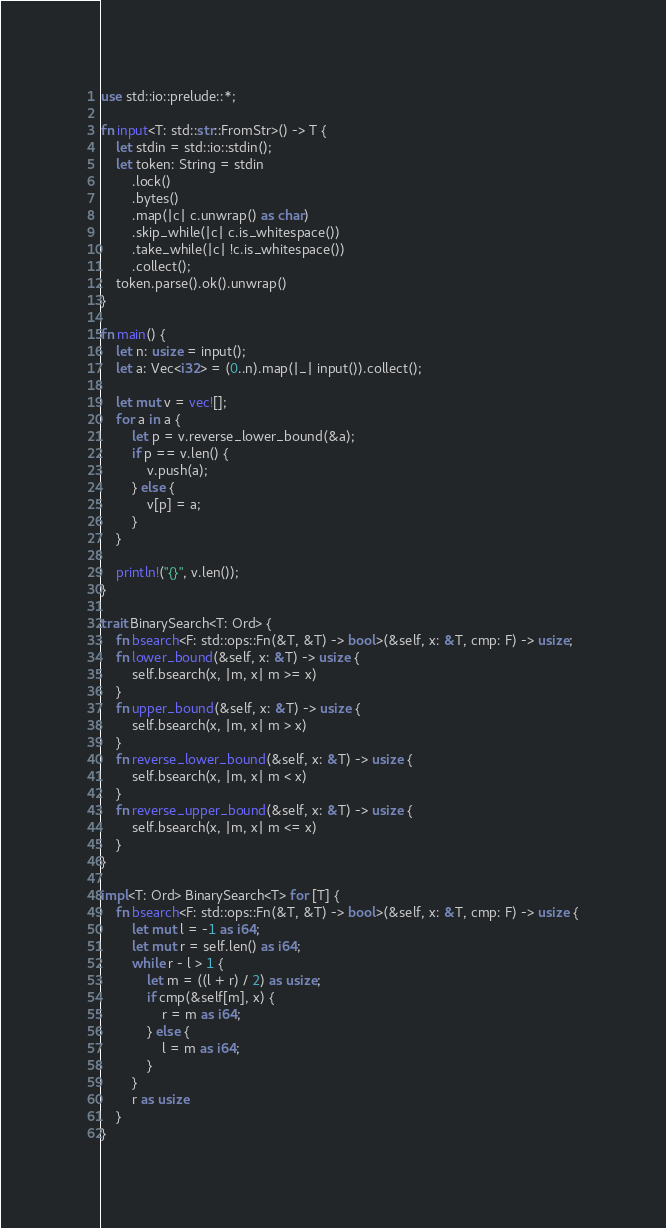Convert code to text. <code><loc_0><loc_0><loc_500><loc_500><_Rust_>use std::io::prelude::*;

fn input<T: std::str::FromStr>() -> T {
    let stdin = std::io::stdin();
    let token: String = stdin
        .lock()
        .bytes()
        .map(|c| c.unwrap() as char)
        .skip_while(|c| c.is_whitespace())
        .take_while(|c| !c.is_whitespace())
        .collect();
    token.parse().ok().unwrap()
}

fn main() {
    let n: usize = input();
    let a: Vec<i32> = (0..n).map(|_| input()).collect();

    let mut v = vec![];
    for a in a {
        let p = v.reverse_lower_bound(&a);
        if p == v.len() {
            v.push(a);
        } else {
            v[p] = a;
        }
    }

    println!("{}", v.len());
}

trait BinarySearch<T: Ord> {
    fn bsearch<F: std::ops::Fn(&T, &T) -> bool>(&self, x: &T, cmp: F) -> usize;
    fn lower_bound(&self, x: &T) -> usize {
        self.bsearch(x, |m, x| m >= x)
    }
    fn upper_bound(&self, x: &T) -> usize {
        self.bsearch(x, |m, x| m > x)
    }
    fn reverse_lower_bound(&self, x: &T) -> usize {
        self.bsearch(x, |m, x| m < x)
    }
    fn reverse_upper_bound(&self, x: &T) -> usize {
        self.bsearch(x, |m, x| m <= x)
    }
}

impl<T: Ord> BinarySearch<T> for [T] {
    fn bsearch<F: std::ops::Fn(&T, &T) -> bool>(&self, x: &T, cmp: F) -> usize {
        let mut l = -1 as i64;
        let mut r = self.len() as i64;
        while r - l > 1 {
            let m = ((l + r) / 2) as usize;
            if cmp(&self[m], x) {
                r = m as i64;
            } else {
                l = m as i64;
            }
        }
        r as usize
    }
}
</code> 